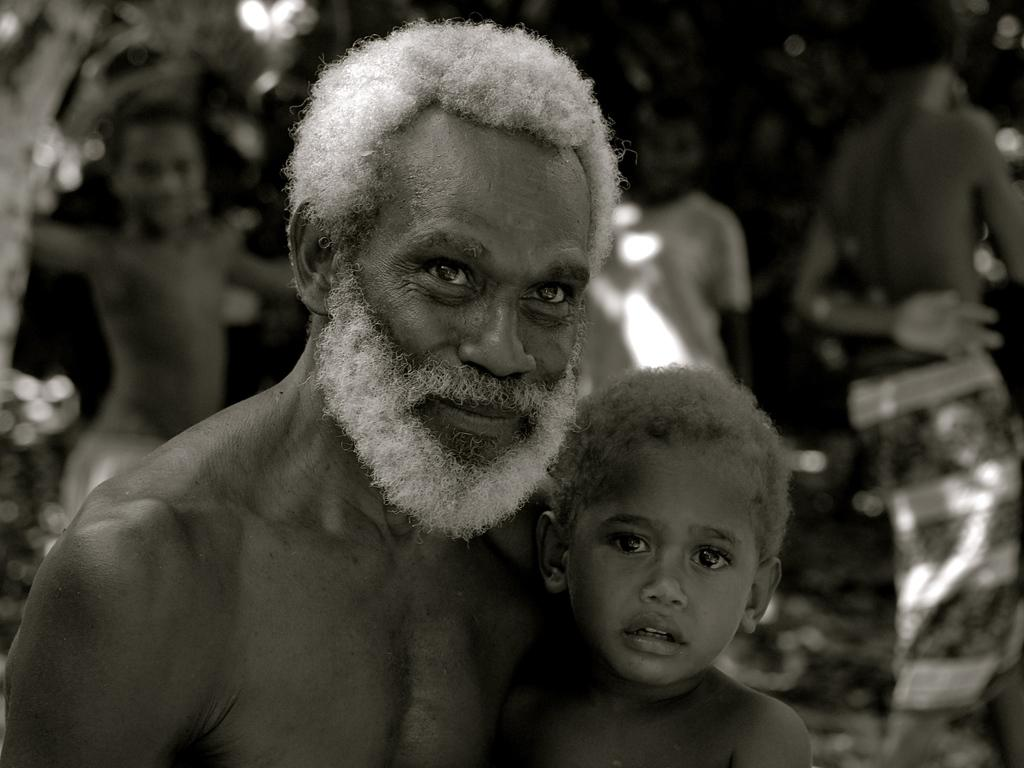What is the color scheme of the image? The image is black and white. Who is present in the image? There is a man and a boy in the image. How are the man and boy related in the image? The man and boy are together in the image. Can you describe the background of the image? The background of the image is blurred, and there are people and other objects in the background. How does the man stretch his arms in the image? There is no indication in the image that the man is stretching his arms; he is simply standing with the boy. What type of connection is established between the man and the boy in the image? The image does not show a specific type of connection between the man and the boy, only that they are together. 